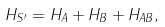Convert formula to latex. <formula><loc_0><loc_0><loc_500><loc_500>H _ { S ^ { \prime } } = H _ { A } + H _ { B } + H _ { A B } ,</formula> 